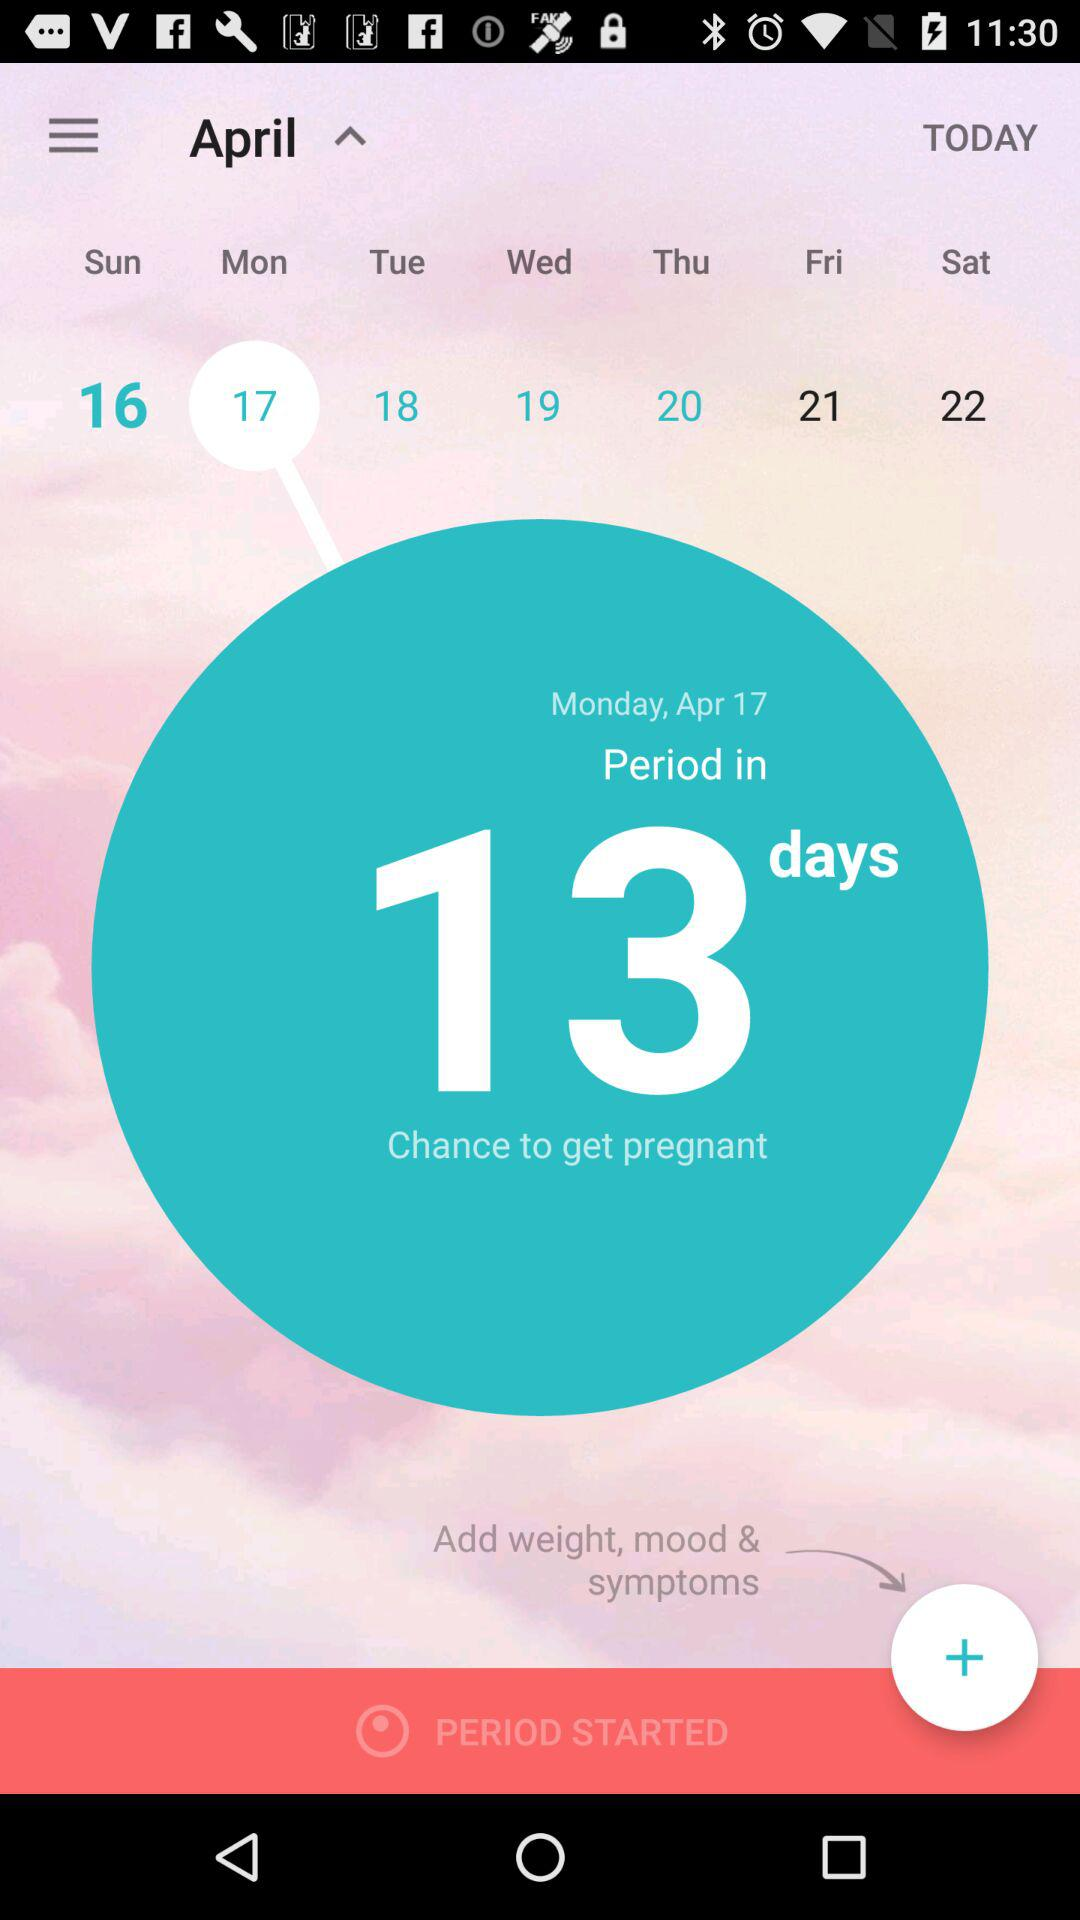What is the expected period date?
When the provided information is insufficient, respond with <no answer>. <no answer> 